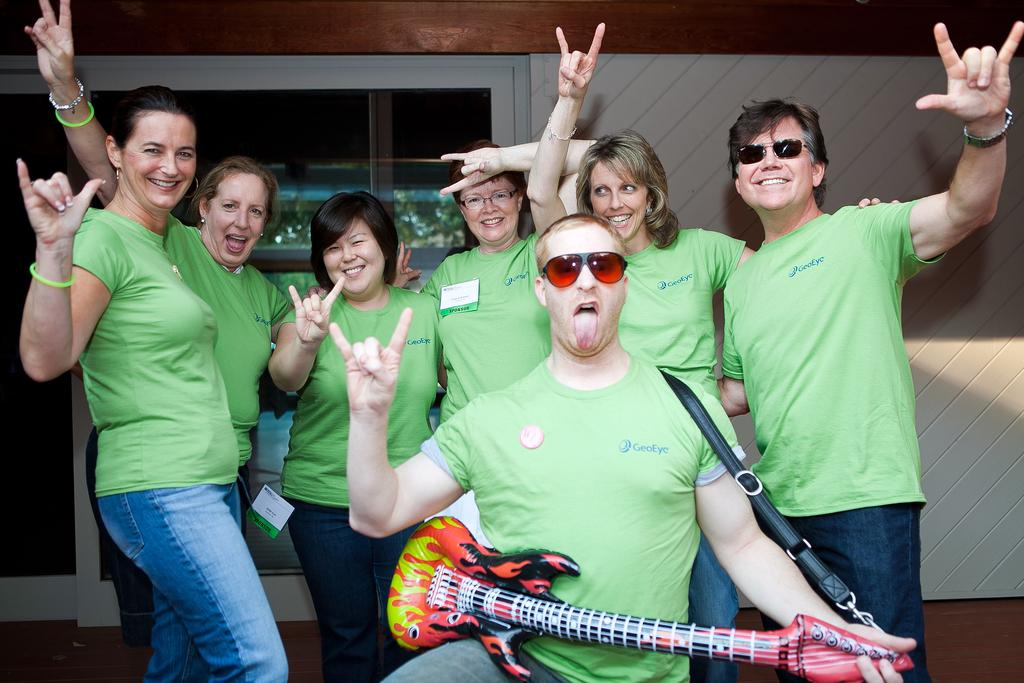How many people are in the image? There is a group of people in the image. What are the people in the image doing? The people are standing and laughing. Is there anyone in the image holding an instrument? Yes, there is a person holding a guitar. How would you describe the expression of the person with the guitar? The person with the guitar has a weird expression. What can be seen in the background of the image? There is a wall and a glass door in the background of the image. What type of railway can be seen in the image? There is no railway present in the image. Are there any trees visible in the image? There is no mention of trees in the provided facts, so we cannot determine if they are present in the image. 